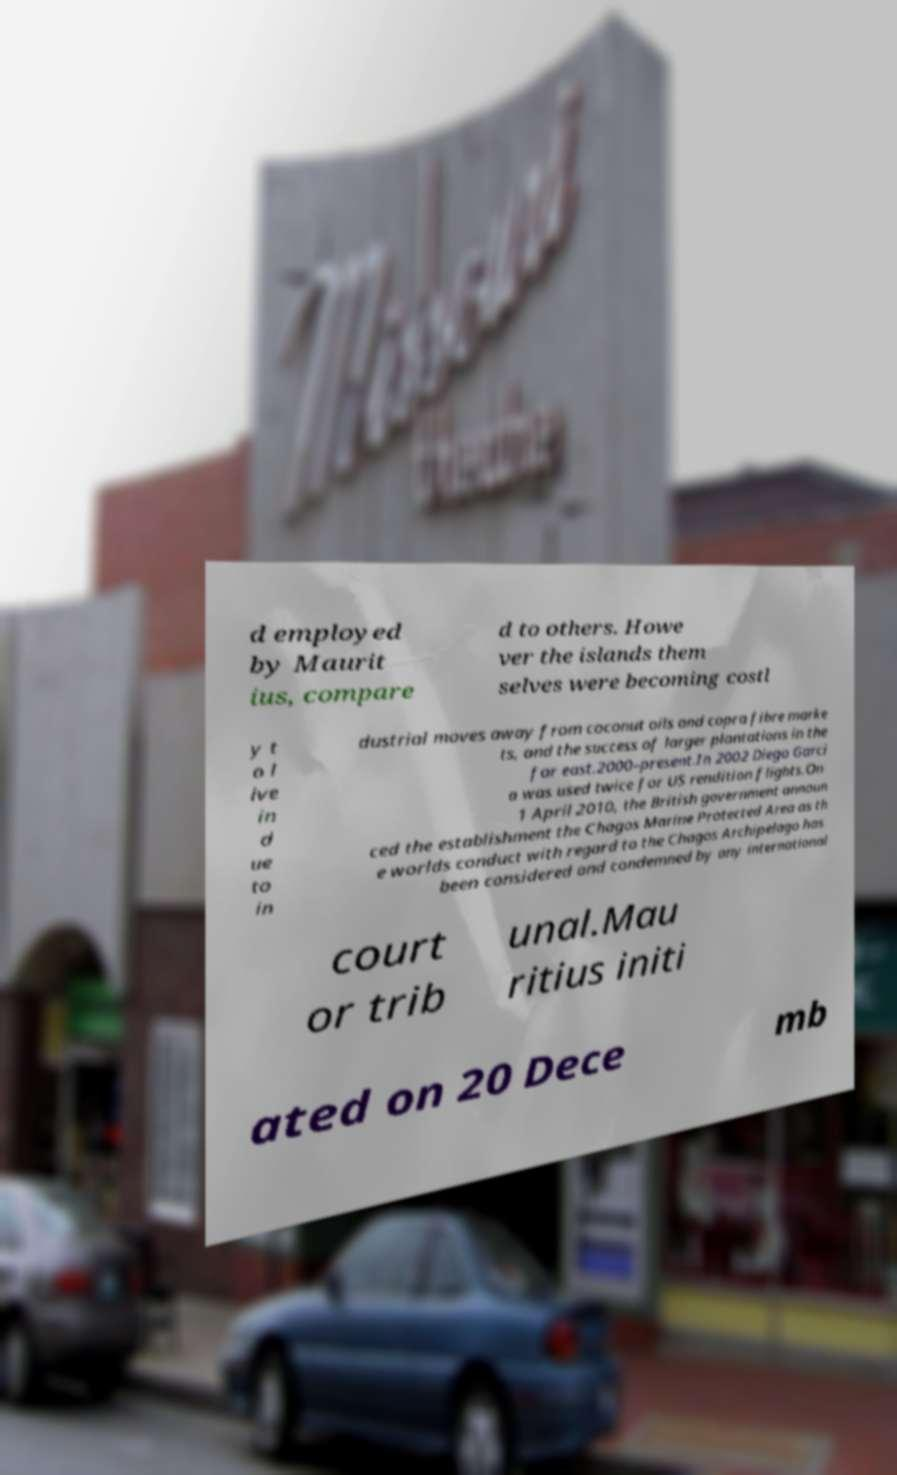There's text embedded in this image that I need extracted. Can you transcribe it verbatim? d employed by Maurit ius, compare d to others. Howe ver the islands them selves were becoming costl y t o l ive in d ue to in dustrial moves away from coconut oils and copra fibre marke ts, and the success of larger plantations in the far east.2000–present.In 2002 Diego Garci a was used twice for US rendition flights.On 1 April 2010, the British government announ ced the establishment the Chagos Marine Protected Area as th e worlds conduct with regard to the Chagos Archipelago has been considered and condemned by any international court or trib unal.Mau ritius initi ated on 20 Dece mb 